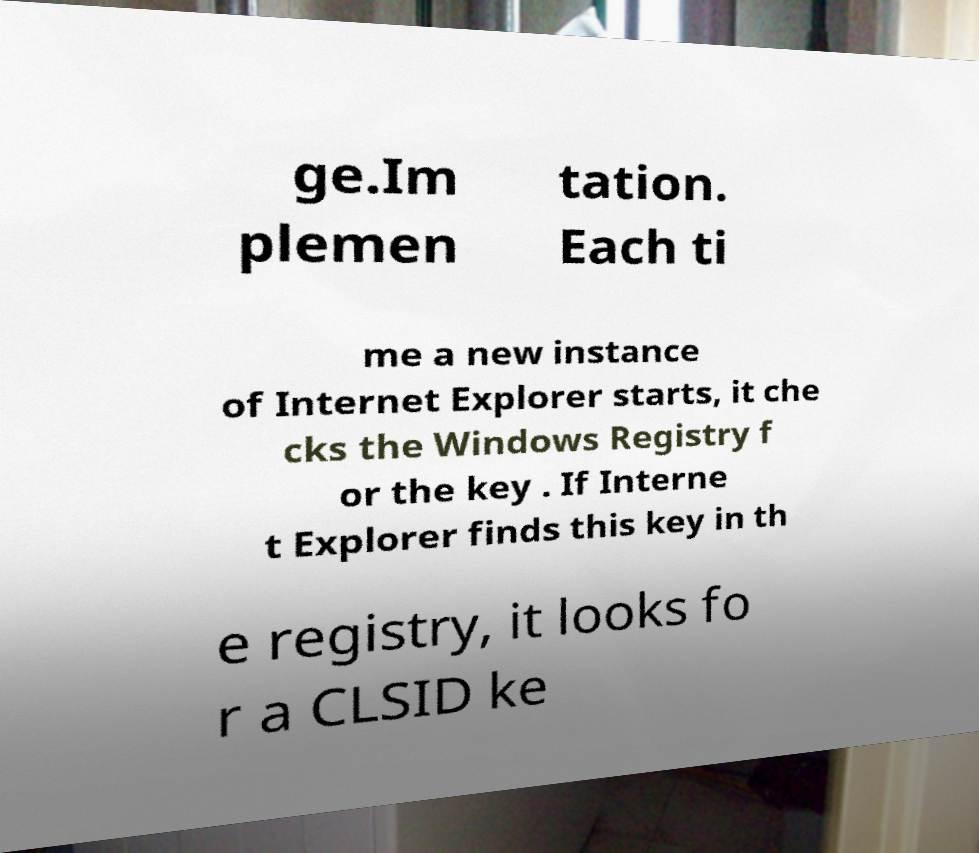Can you read and provide the text displayed in the image?This photo seems to have some interesting text. Can you extract and type it out for me? ge.Im plemen tation. Each ti me a new instance of Internet Explorer starts, it che cks the Windows Registry f or the key . If Interne t Explorer finds this key in th e registry, it looks fo r a CLSID ke 